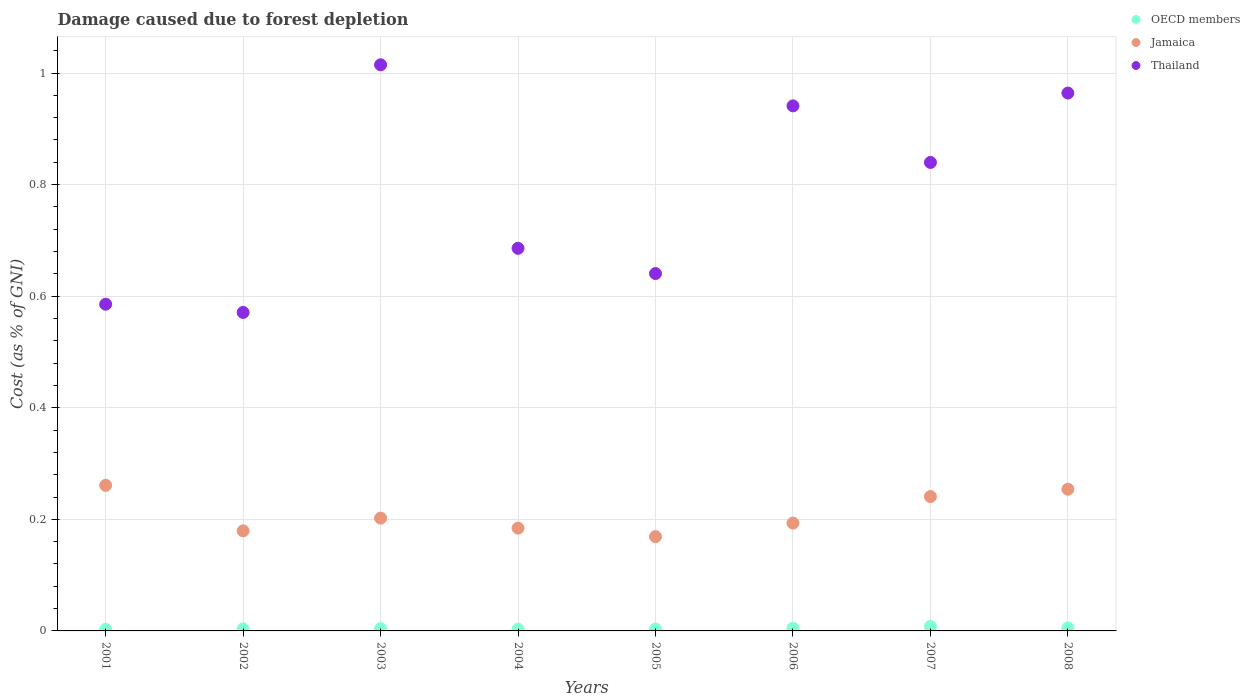How many different coloured dotlines are there?
Keep it short and to the point. 3. Is the number of dotlines equal to the number of legend labels?
Your response must be concise. Yes. What is the cost of damage caused due to forest depletion in Jamaica in 2003?
Make the answer very short. 0.2. Across all years, what is the maximum cost of damage caused due to forest depletion in Thailand?
Your answer should be very brief. 1.01. Across all years, what is the minimum cost of damage caused due to forest depletion in Thailand?
Provide a succinct answer. 0.57. In which year was the cost of damage caused due to forest depletion in Thailand maximum?
Keep it short and to the point. 2003. In which year was the cost of damage caused due to forest depletion in OECD members minimum?
Offer a terse response. 2001. What is the total cost of damage caused due to forest depletion in Jamaica in the graph?
Your answer should be very brief. 1.68. What is the difference between the cost of damage caused due to forest depletion in OECD members in 2001 and that in 2004?
Make the answer very short. -0. What is the difference between the cost of damage caused due to forest depletion in Jamaica in 2004 and the cost of damage caused due to forest depletion in Thailand in 2008?
Your answer should be very brief. -0.78. What is the average cost of damage caused due to forest depletion in Jamaica per year?
Give a very brief answer. 0.21. In the year 2008, what is the difference between the cost of damage caused due to forest depletion in Jamaica and cost of damage caused due to forest depletion in OECD members?
Offer a very short reply. 0.25. What is the ratio of the cost of damage caused due to forest depletion in Jamaica in 2002 to that in 2003?
Give a very brief answer. 0.89. Is the cost of damage caused due to forest depletion in OECD members in 2002 less than that in 2003?
Provide a succinct answer. Yes. Is the difference between the cost of damage caused due to forest depletion in Jamaica in 2007 and 2008 greater than the difference between the cost of damage caused due to forest depletion in OECD members in 2007 and 2008?
Offer a terse response. No. What is the difference between the highest and the second highest cost of damage caused due to forest depletion in Thailand?
Your response must be concise. 0.05. What is the difference between the highest and the lowest cost of damage caused due to forest depletion in Jamaica?
Give a very brief answer. 0.09. In how many years, is the cost of damage caused due to forest depletion in Thailand greater than the average cost of damage caused due to forest depletion in Thailand taken over all years?
Your answer should be very brief. 4. Is the sum of the cost of damage caused due to forest depletion in Jamaica in 2001 and 2002 greater than the maximum cost of damage caused due to forest depletion in Thailand across all years?
Your response must be concise. No. Is the cost of damage caused due to forest depletion in Thailand strictly less than the cost of damage caused due to forest depletion in OECD members over the years?
Make the answer very short. No. Are the values on the major ticks of Y-axis written in scientific E-notation?
Provide a succinct answer. No. Where does the legend appear in the graph?
Ensure brevity in your answer.  Top right. How many legend labels are there?
Offer a very short reply. 3. What is the title of the graph?
Your answer should be compact. Damage caused due to forest depletion. What is the label or title of the X-axis?
Give a very brief answer. Years. What is the label or title of the Y-axis?
Offer a very short reply. Cost (as % of GNI). What is the Cost (as % of GNI) in OECD members in 2001?
Your answer should be compact. 0. What is the Cost (as % of GNI) of Jamaica in 2001?
Provide a succinct answer. 0.26. What is the Cost (as % of GNI) in Thailand in 2001?
Provide a succinct answer. 0.59. What is the Cost (as % of GNI) of OECD members in 2002?
Provide a succinct answer. 0. What is the Cost (as % of GNI) of Jamaica in 2002?
Your response must be concise. 0.18. What is the Cost (as % of GNI) in Thailand in 2002?
Your response must be concise. 0.57. What is the Cost (as % of GNI) of OECD members in 2003?
Your answer should be compact. 0. What is the Cost (as % of GNI) of Jamaica in 2003?
Ensure brevity in your answer.  0.2. What is the Cost (as % of GNI) of Thailand in 2003?
Your response must be concise. 1.01. What is the Cost (as % of GNI) in OECD members in 2004?
Make the answer very short. 0. What is the Cost (as % of GNI) of Jamaica in 2004?
Your answer should be very brief. 0.18. What is the Cost (as % of GNI) in Thailand in 2004?
Offer a terse response. 0.69. What is the Cost (as % of GNI) of OECD members in 2005?
Make the answer very short. 0. What is the Cost (as % of GNI) in Jamaica in 2005?
Provide a short and direct response. 0.17. What is the Cost (as % of GNI) in Thailand in 2005?
Give a very brief answer. 0.64. What is the Cost (as % of GNI) of OECD members in 2006?
Give a very brief answer. 0. What is the Cost (as % of GNI) in Jamaica in 2006?
Provide a succinct answer. 0.19. What is the Cost (as % of GNI) in Thailand in 2006?
Your answer should be compact. 0.94. What is the Cost (as % of GNI) in OECD members in 2007?
Your answer should be compact. 0.01. What is the Cost (as % of GNI) of Jamaica in 2007?
Offer a very short reply. 0.24. What is the Cost (as % of GNI) of Thailand in 2007?
Provide a succinct answer. 0.84. What is the Cost (as % of GNI) of OECD members in 2008?
Make the answer very short. 0.01. What is the Cost (as % of GNI) of Jamaica in 2008?
Keep it short and to the point. 0.25. What is the Cost (as % of GNI) of Thailand in 2008?
Provide a short and direct response. 0.96. Across all years, what is the maximum Cost (as % of GNI) in OECD members?
Your response must be concise. 0.01. Across all years, what is the maximum Cost (as % of GNI) of Jamaica?
Offer a very short reply. 0.26. Across all years, what is the maximum Cost (as % of GNI) in Thailand?
Keep it short and to the point. 1.01. Across all years, what is the minimum Cost (as % of GNI) of OECD members?
Provide a succinct answer. 0. Across all years, what is the minimum Cost (as % of GNI) in Jamaica?
Offer a very short reply. 0.17. Across all years, what is the minimum Cost (as % of GNI) in Thailand?
Offer a terse response. 0.57. What is the total Cost (as % of GNI) in OECD members in the graph?
Your answer should be compact. 0.04. What is the total Cost (as % of GNI) of Jamaica in the graph?
Give a very brief answer. 1.68. What is the total Cost (as % of GNI) in Thailand in the graph?
Offer a terse response. 6.24. What is the difference between the Cost (as % of GNI) of OECD members in 2001 and that in 2002?
Your answer should be compact. -0. What is the difference between the Cost (as % of GNI) in Jamaica in 2001 and that in 2002?
Offer a very short reply. 0.08. What is the difference between the Cost (as % of GNI) of Thailand in 2001 and that in 2002?
Your response must be concise. 0.01. What is the difference between the Cost (as % of GNI) in OECD members in 2001 and that in 2003?
Offer a terse response. -0. What is the difference between the Cost (as % of GNI) in Jamaica in 2001 and that in 2003?
Your response must be concise. 0.06. What is the difference between the Cost (as % of GNI) in Thailand in 2001 and that in 2003?
Your answer should be very brief. -0.43. What is the difference between the Cost (as % of GNI) in OECD members in 2001 and that in 2004?
Provide a short and direct response. -0. What is the difference between the Cost (as % of GNI) in Jamaica in 2001 and that in 2004?
Offer a terse response. 0.08. What is the difference between the Cost (as % of GNI) of Thailand in 2001 and that in 2004?
Provide a short and direct response. -0.1. What is the difference between the Cost (as % of GNI) of OECD members in 2001 and that in 2005?
Make the answer very short. -0. What is the difference between the Cost (as % of GNI) in Jamaica in 2001 and that in 2005?
Your answer should be compact. 0.09. What is the difference between the Cost (as % of GNI) in Thailand in 2001 and that in 2005?
Ensure brevity in your answer.  -0.06. What is the difference between the Cost (as % of GNI) in OECD members in 2001 and that in 2006?
Provide a short and direct response. -0. What is the difference between the Cost (as % of GNI) in Jamaica in 2001 and that in 2006?
Provide a succinct answer. 0.07. What is the difference between the Cost (as % of GNI) in Thailand in 2001 and that in 2006?
Keep it short and to the point. -0.36. What is the difference between the Cost (as % of GNI) of OECD members in 2001 and that in 2007?
Offer a very short reply. -0. What is the difference between the Cost (as % of GNI) of Jamaica in 2001 and that in 2007?
Keep it short and to the point. 0.02. What is the difference between the Cost (as % of GNI) in Thailand in 2001 and that in 2007?
Your response must be concise. -0.25. What is the difference between the Cost (as % of GNI) of OECD members in 2001 and that in 2008?
Your answer should be very brief. -0. What is the difference between the Cost (as % of GNI) of Jamaica in 2001 and that in 2008?
Keep it short and to the point. 0.01. What is the difference between the Cost (as % of GNI) in Thailand in 2001 and that in 2008?
Your answer should be compact. -0.38. What is the difference between the Cost (as % of GNI) in OECD members in 2002 and that in 2003?
Provide a succinct answer. -0. What is the difference between the Cost (as % of GNI) of Jamaica in 2002 and that in 2003?
Your answer should be compact. -0.02. What is the difference between the Cost (as % of GNI) of Thailand in 2002 and that in 2003?
Provide a succinct answer. -0.44. What is the difference between the Cost (as % of GNI) in OECD members in 2002 and that in 2004?
Your answer should be compact. 0. What is the difference between the Cost (as % of GNI) of Jamaica in 2002 and that in 2004?
Your answer should be very brief. -0. What is the difference between the Cost (as % of GNI) in Thailand in 2002 and that in 2004?
Give a very brief answer. -0.12. What is the difference between the Cost (as % of GNI) in OECD members in 2002 and that in 2005?
Offer a terse response. 0. What is the difference between the Cost (as % of GNI) of Jamaica in 2002 and that in 2005?
Keep it short and to the point. 0.01. What is the difference between the Cost (as % of GNI) in Thailand in 2002 and that in 2005?
Make the answer very short. -0.07. What is the difference between the Cost (as % of GNI) of OECD members in 2002 and that in 2006?
Your response must be concise. -0. What is the difference between the Cost (as % of GNI) in Jamaica in 2002 and that in 2006?
Ensure brevity in your answer.  -0.01. What is the difference between the Cost (as % of GNI) in Thailand in 2002 and that in 2006?
Offer a very short reply. -0.37. What is the difference between the Cost (as % of GNI) of OECD members in 2002 and that in 2007?
Offer a terse response. -0. What is the difference between the Cost (as % of GNI) in Jamaica in 2002 and that in 2007?
Offer a terse response. -0.06. What is the difference between the Cost (as % of GNI) in Thailand in 2002 and that in 2007?
Your answer should be compact. -0.27. What is the difference between the Cost (as % of GNI) in OECD members in 2002 and that in 2008?
Your answer should be compact. -0. What is the difference between the Cost (as % of GNI) of Jamaica in 2002 and that in 2008?
Your answer should be compact. -0.07. What is the difference between the Cost (as % of GNI) of Thailand in 2002 and that in 2008?
Ensure brevity in your answer.  -0.39. What is the difference between the Cost (as % of GNI) of OECD members in 2003 and that in 2004?
Offer a terse response. 0. What is the difference between the Cost (as % of GNI) of Jamaica in 2003 and that in 2004?
Your answer should be compact. 0.02. What is the difference between the Cost (as % of GNI) in Thailand in 2003 and that in 2004?
Your answer should be very brief. 0.33. What is the difference between the Cost (as % of GNI) of OECD members in 2003 and that in 2005?
Give a very brief answer. 0. What is the difference between the Cost (as % of GNI) of Jamaica in 2003 and that in 2005?
Offer a terse response. 0.03. What is the difference between the Cost (as % of GNI) in Thailand in 2003 and that in 2005?
Provide a succinct answer. 0.37. What is the difference between the Cost (as % of GNI) in OECD members in 2003 and that in 2006?
Your answer should be compact. -0. What is the difference between the Cost (as % of GNI) in Jamaica in 2003 and that in 2006?
Ensure brevity in your answer.  0.01. What is the difference between the Cost (as % of GNI) of Thailand in 2003 and that in 2006?
Make the answer very short. 0.07. What is the difference between the Cost (as % of GNI) of OECD members in 2003 and that in 2007?
Offer a very short reply. -0. What is the difference between the Cost (as % of GNI) in Jamaica in 2003 and that in 2007?
Your answer should be compact. -0.04. What is the difference between the Cost (as % of GNI) in Thailand in 2003 and that in 2007?
Provide a succinct answer. 0.17. What is the difference between the Cost (as % of GNI) in OECD members in 2003 and that in 2008?
Offer a very short reply. -0. What is the difference between the Cost (as % of GNI) of Jamaica in 2003 and that in 2008?
Your answer should be very brief. -0.05. What is the difference between the Cost (as % of GNI) of Thailand in 2003 and that in 2008?
Provide a short and direct response. 0.05. What is the difference between the Cost (as % of GNI) of OECD members in 2004 and that in 2005?
Ensure brevity in your answer.  -0. What is the difference between the Cost (as % of GNI) in Jamaica in 2004 and that in 2005?
Your response must be concise. 0.02. What is the difference between the Cost (as % of GNI) of Thailand in 2004 and that in 2005?
Provide a succinct answer. 0.05. What is the difference between the Cost (as % of GNI) in OECD members in 2004 and that in 2006?
Provide a short and direct response. -0. What is the difference between the Cost (as % of GNI) in Jamaica in 2004 and that in 2006?
Keep it short and to the point. -0.01. What is the difference between the Cost (as % of GNI) of Thailand in 2004 and that in 2006?
Your response must be concise. -0.26. What is the difference between the Cost (as % of GNI) of OECD members in 2004 and that in 2007?
Make the answer very short. -0. What is the difference between the Cost (as % of GNI) of Jamaica in 2004 and that in 2007?
Offer a terse response. -0.06. What is the difference between the Cost (as % of GNI) in Thailand in 2004 and that in 2007?
Keep it short and to the point. -0.15. What is the difference between the Cost (as % of GNI) in OECD members in 2004 and that in 2008?
Your answer should be very brief. -0. What is the difference between the Cost (as % of GNI) of Jamaica in 2004 and that in 2008?
Your response must be concise. -0.07. What is the difference between the Cost (as % of GNI) of Thailand in 2004 and that in 2008?
Give a very brief answer. -0.28. What is the difference between the Cost (as % of GNI) of OECD members in 2005 and that in 2006?
Your response must be concise. -0. What is the difference between the Cost (as % of GNI) of Jamaica in 2005 and that in 2006?
Your answer should be compact. -0.02. What is the difference between the Cost (as % of GNI) in Thailand in 2005 and that in 2006?
Provide a short and direct response. -0.3. What is the difference between the Cost (as % of GNI) of OECD members in 2005 and that in 2007?
Your response must be concise. -0. What is the difference between the Cost (as % of GNI) in Jamaica in 2005 and that in 2007?
Make the answer very short. -0.07. What is the difference between the Cost (as % of GNI) of Thailand in 2005 and that in 2007?
Your response must be concise. -0.2. What is the difference between the Cost (as % of GNI) in OECD members in 2005 and that in 2008?
Give a very brief answer. -0. What is the difference between the Cost (as % of GNI) of Jamaica in 2005 and that in 2008?
Your response must be concise. -0.09. What is the difference between the Cost (as % of GNI) of Thailand in 2005 and that in 2008?
Your answer should be compact. -0.32. What is the difference between the Cost (as % of GNI) of OECD members in 2006 and that in 2007?
Provide a short and direct response. -0. What is the difference between the Cost (as % of GNI) in Jamaica in 2006 and that in 2007?
Offer a terse response. -0.05. What is the difference between the Cost (as % of GNI) of Thailand in 2006 and that in 2007?
Ensure brevity in your answer.  0.1. What is the difference between the Cost (as % of GNI) in OECD members in 2006 and that in 2008?
Your answer should be very brief. -0. What is the difference between the Cost (as % of GNI) of Jamaica in 2006 and that in 2008?
Offer a very short reply. -0.06. What is the difference between the Cost (as % of GNI) in Thailand in 2006 and that in 2008?
Give a very brief answer. -0.02. What is the difference between the Cost (as % of GNI) in OECD members in 2007 and that in 2008?
Your answer should be very brief. 0. What is the difference between the Cost (as % of GNI) in Jamaica in 2007 and that in 2008?
Ensure brevity in your answer.  -0.01. What is the difference between the Cost (as % of GNI) in Thailand in 2007 and that in 2008?
Give a very brief answer. -0.12. What is the difference between the Cost (as % of GNI) of OECD members in 2001 and the Cost (as % of GNI) of Jamaica in 2002?
Make the answer very short. -0.18. What is the difference between the Cost (as % of GNI) of OECD members in 2001 and the Cost (as % of GNI) of Thailand in 2002?
Provide a succinct answer. -0.57. What is the difference between the Cost (as % of GNI) in Jamaica in 2001 and the Cost (as % of GNI) in Thailand in 2002?
Your answer should be very brief. -0.31. What is the difference between the Cost (as % of GNI) in OECD members in 2001 and the Cost (as % of GNI) in Jamaica in 2003?
Your answer should be compact. -0.2. What is the difference between the Cost (as % of GNI) of OECD members in 2001 and the Cost (as % of GNI) of Thailand in 2003?
Offer a very short reply. -1.01. What is the difference between the Cost (as % of GNI) in Jamaica in 2001 and the Cost (as % of GNI) in Thailand in 2003?
Offer a terse response. -0.75. What is the difference between the Cost (as % of GNI) in OECD members in 2001 and the Cost (as % of GNI) in Jamaica in 2004?
Ensure brevity in your answer.  -0.18. What is the difference between the Cost (as % of GNI) in OECD members in 2001 and the Cost (as % of GNI) in Thailand in 2004?
Offer a very short reply. -0.68. What is the difference between the Cost (as % of GNI) of Jamaica in 2001 and the Cost (as % of GNI) of Thailand in 2004?
Provide a short and direct response. -0.42. What is the difference between the Cost (as % of GNI) in OECD members in 2001 and the Cost (as % of GNI) in Jamaica in 2005?
Provide a short and direct response. -0.17. What is the difference between the Cost (as % of GNI) in OECD members in 2001 and the Cost (as % of GNI) in Thailand in 2005?
Give a very brief answer. -0.64. What is the difference between the Cost (as % of GNI) of Jamaica in 2001 and the Cost (as % of GNI) of Thailand in 2005?
Your answer should be very brief. -0.38. What is the difference between the Cost (as % of GNI) of OECD members in 2001 and the Cost (as % of GNI) of Jamaica in 2006?
Give a very brief answer. -0.19. What is the difference between the Cost (as % of GNI) in OECD members in 2001 and the Cost (as % of GNI) in Thailand in 2006?
Offer a very short reply. -0.94. What is the difference between the Cost (as % of GNI) in Jamaica in 2001 and the Cost (as % of GNI) in Thailand in 2006?
Provide a succinct answer. -0.68. What is the difference between the Cost (as % of GNI) of OECD members in 2001 and the Cost (as % of GNI) of Jamaica in 2007?
Your response must be concise. -0.24. What is the difference between the Cost (as % of GNI) of OECD members in 2001 and the Cost (as % of GNI) of Thailand in 2007?
Your answer should be very brief. -0.84. What is the difference between the Cost (as % of GNI) of Jamaica in 2001 and the Cost (as % of GNI) of Thailand in 2007?
Give a very brief answer. -0.58. What is the difference between the Cost (as % of GNI) in OECD members in 2001 and the Cost (as % of GNI) in Jamaica in 2008?
Make the answer very short. -0.25. What is the difference between the Cost (as % of GNI) in OECD members in 2001 and the Cost (as % of GNI) in Thailand in 2008?
Give a very brief answer. -0.96. What is the difference between the Cost (as % of GNI) of Jamaica in 2001 and the Cost (as % of GNI) of Thailand in 2008?
Keep it short and to the point. -0.7. What is the difference between the Cost (as % of GNI) of OECD members in 2002 and the Cost (as % of GNI) of Jamaica in 2003?
Ensure brevity in your answer.  -0.2. What is the difference between the Cost (as % of GNI) of OECD members in 2002 and the Cost (as % of GNI) of Thailand in 2003?
Make the answer very short. -1.01. What is the difference between the Cost (as % of GNI) of Jamaica in 2002 and the Cost (as % of GNI) of Thailand in 2003?
Your answer should be compact. -0.84. What is the difference between the Cost (as % of GNI) of OECD members in 2002 and the Cost (as % of GNI) of Jamaica in 2004?
Provide a succinct answer. -0.18. What is the difference between the Cost (as % of GNI) of OECD members in 2002 and the Cost (as % of GNI) of Thailand in 2004?
Keep it short and to the point. -0.68. What is the difference between the Cost (as % of GNI) in Jamaica in 2002 and the Cost (as % of GNI) in Thailand in 2004?
Offer a very short reply. -0.51. What is the difference between the Cost (as % of GNI) of OECD members in 2002 and the Cost (as % of GNI) of Jamaica in 2005?
Your response must be concise. -0.17. What is the difference between the Cost (as % of GNI) of OECD members in 2002 and the Cost (as % of GNI) of Thailand in 2005?
Give a very brief answer. -0.64. What is the difference between the Cost (as % of GNI) in Jamaica in 2002 and the Cost (as % of GNI) in Thailand in 2005?
Keep it short and to the point. -0.46. What is the difference between the Cost (as % of GNI) in OECD members in 2002 and the Cost (as % of GNI) in Jamaica in 2006?
Your response must be concise. -0.19. What is the difference between the Cost (as % of GNI) of OECD members in 2002 and the Cost (as % of GNI) of Thailand in 2006?
Give a very brief answer. -0.94. What is the difference between the Cost (as % of GNI) of Jamaica in 2002 and the Cost (as % of GNI) of Thailand in 2006?
Offer a very short reply. -0.76. What is the difference between the Cost (as % of GNI) of OECD members in 2002 and the Cost (as % of GNI) of Jamaica in 2007?
Offer a very short reply. -0.24. What is the difference between the Cost (as % of GNI) of OECD members in 2002 and the Cost (as % of GNI) of Thailand in 2007?
Your answer should be very brief. -0.84. What is the difference between the Cost (as % of GNI) in Jamaica in 2002 and the Cost (as % of GNI) in Thailand in 2007?
Provide a short and direct response. -0.66. What is the difference between the Cost (as % of GNI) of OECD members in 2002 and the Cost (as % of GNI) of Jamaica in 2008?
Give a very brief answer. -0.25. What is the difference between the Cost (as % of GNI) of OECD members in 2002 and the Cost (as % of GNI) of Thailand in 2008?
Make the answer very short. -0.96. What is the difference between the Cost (as % of GNI) of Jamaica in 2002 and the Cost (as % of GNI) of Thailand in 2008?
Make the answer very short. -0.78. What is the difference between the Cost (as % of GNI) in OECD members in 2003 and the Cost (as % of GNI) in Jamaica in 2004?
Provide a succinct answer. -0.18. What is the difference between the Cost (as % of GNI) of OECD members in 2003 and the Cost (as % of GNI) of Thailand in 2004?
Ensure brevity in your answer.  -0.68. What is the difference between the Cost (as % of GNI) of Jamaica in 2003 and the Cost (as % of GNI) of Thailand in 2004?
Your response must be concise. -0.48. What is the difference between the Cost (as % of GNI) of OECD members in 2003 and the Cost (as % of GNI) of Jamaica in 2005?
Ensure brevity in your answer.  -0.16. What is the difference between the Cost (as % of GNI) of OECD members in 2003 and the Cost (as % of GNI) of Thailand in 2005?
Give a very brief answer. -0.64. What is the difference between the Cost (as % of GNI) in Jamaica in 2003 and the Cost (as % of GNI) in Thailand in 2005?
Your answer should be very brief. -0.44. What is the difference between the Cost (as % of GNI) in OECD members in 2003 and the Cost (as % of GNI) in Jamaica in 2006?
Your answer should be very brief. -0.19. What is the difference between the Cost (as % of GNI) in OECD members in 2003 and the Cost (as % of GNI) in Thailand in 2006?
Your answer should be very brief. -0.94. What is the difference between the Cost (as % of GNI) in Jamaica in 2003 and the Cost (as % of GNI) in Thailand in 2006?
Offer a terse response. -0.74. What is the difference between the Cost (as % of GNI) in OECD members in 2003 and the Cost (as % of GNI) in Jamaica in 2007?
Offer a very short reply. -0.24. What is the difference between the Cost (as % of GNI) of OECD members in 2003 and the Cost (as % of GNI) of Thailand in 2007?
Provide a short and direct response. -0.84. What is the difference between the Cost (as % of GNI) in Jamaica in 2003 and the Cost (as % of GNI) in Thailand in 2007?
Your response must be concise. -0.64. What is the difference between the Cost (as % of GNI) of OECD members in 2003 and the Cost (as % of GNI) of Jamaica in 2008?
Make the answer very short. -0.25. What is the difference between the Cost (as % of GNI) of OECD members in 2003 and the Cost (as % of GNI) of Thailand in 2008?
Your answer should be compact. -0.96. What is the difference between the Cost (as % of GNI) in Jamaica in 2003 and the Cost (as % of GNI) in Thailand in 2008?
Offer a very short reply. -0.76. What is the difference between the Cost (as % of GNI) of OECD members in 2004 and the Cost (as % of GNI) of Jamaica in 2005?
Your response must be concise. -0.17. What is the difference between the Cost (as % of GNI) in OECD members in 2004 and the Cost (as % of GNI) in Thailand in 2005?
Your answer should be compact. -0.64. What is the difference between the Cost (as % of GNI) of Jamaica in 2004 and the Cost (as % of GNI) of Thailand in 2005?
Keep it short and to the point. -0.46. What is the difference between the Cost (as % of GNI) in OECD members in 2004 and the Cost (as % of GNI) in Jamaica in 2006?
Make the answer very short. -0.19. What is the difference between the Cost (as % of GNI) of OECD members in 2004 and the Cost (as % of GNI) of Thailand in 2006?
Make the answer very short. -0.94. What is the difference between the Cost (as % of GNI) in Jamaica in 2004 and the Cost (as % of GNI) in Thailand in 2006?
Offer a terse response. -0.76. What is the difference between the Cost (as % of GNI) of OECD members in 2004 and the Cost (as % of GNI) of Jamaica in 2007?
Provide a short and direct response. -0.24. What is the difference between the Cost (as % of GNI) of OECD members in 2004 and the Cost (as % of GNI) of Thailand in 2007?
Your answer should be very brief. -0.84. What is the difference between the Cost (as % of GNI) of Jamaica in 2004 and the Cost (as % of GNI) of Thailand in 2007?
Your answer should be very brief. -0.66. What is the difference between the Cost (as % of GNI) in OECD members in 2004 and the Cost (as % of GNI) in Jamaica in 2008?
Provide a short and direct response. -0.25. What is the difference between the Cost (as % of GNI) of OECD members in 2004 and the Cost (as % of GNI) of Thailand in 2008?
Keep it short and to the point. -0.96. What is the difference between the Cost (as % of GNI) of Jamaica in 2004 and the Cost (as % of GNI) of Thailand in 2008?
Ensure brevity in your answer.  -0.78. What is the difference between the Cost (as % of GNI) in OECD members in 2005 and the Cost (as % of GNI) in Jamaica in 2006?
Your answer should be compact. -0.19. What is the difference between the Cost (as % of GNI) in OECD members in 2005 and the Cost (as % of GNI) in Thailand in 2006?
Keep it short and to the point. -0.94. What is the difference between the Cost (as % of GNI) of Jamaica in 2005 and the Cost (as % of GNI) of Thailand in 2006?
Provide a short and direct response. -0.77. What is the difference between the Cost (as % of GNI) in OECD members in 2005 and the Cost (as % of GNI) in Jamaica in 2007?
Provide a short and direct response. -0.24. What is the difference between the Cost (as % of GNI) of OECD members in 2005 and the Cost (as % of GNI) of Thailand in 2007?
Provide a succinct answer. -0.84. What is the difference between the Cost (as % of GNI) of Jamaica in 2005 and the Cost (as % of GNI) of Thailand in 2007?
Provide a short and direct response. -0.67. What is the difference between the Cost (as % of GNI) in OECD members in 2005 and the Cost (as % of GNI) in Jamaica in 2008?
Your response must be concise. -0.25. What is the difference between the Cost (as % of GNI) in OECD members in 2005 and the Cost (as % of GNI) in Thailand in 2008?
Ensure brevity in your answer.  -0.96. What is the difference between the Cost (as % of GNI) in Jamaica in 2005 and the Cost (as % of GNI) in Thailand in 2008?
Your response must be concise. -0.8. What is the difference between the Cost (as % of GNI) of OECD members in 2006 and the Cost (as % of GNI) of Jamaica in 2007?
Provide a short and direct response. -0.24. What is the difference between the Cost (as % of GNI) of OECD members in 2006 and the Cost (as % of GNI) of Thailand in 2007?
Keep it short and to the point. -0.83. What is the difference between the Cost (as % of GNI) in Jamaica in 2006 and the Cost (as % of GNI) in Thailand in 2007?
Your answer should be very brief. -0.65. What is the difference between the Cost (as % of GNI) of OECD members in 2006 and the Cost (as % of GNI) of Jamaica in 2008?
Your answer should be compact. -0.25. What is the difference between the Cost (as % of GNI) in OECD members in 2006 and the Cost (as % of GNI) in Thailand in 2008?
Your response must be concise. -0.96. What is the difference between the Cost (as % of GNI) of Jamaica in 2006 and the Cost (as % of GNI) of Thailand in 2008?
Offer a very short reply. -0.77. What is the difference between the Cost (as % of GNI) of OECD members in 2007 and the Cost (as % of GNI) of Jamaica in 2008?
Your answer should be very brief. -0.25. What is the difference between the Cost (as % of GNI) of OECD members in 2007 and the Cost (as % of GNI) of Thailand in 2008?
Offer a very short reply. -0.96. What is the difference between the Cost (as % of GNI) of Jamaica in 2007 and the Cost (as % of GNI) of Thailand in 2008?
Offer a very short reply. -0.72. What is the average Cost (as % of GNI) of OECD members per year?
Offer a terse response. 0. What is the average Cost (as % of GNI) of Jamaica per year?
Ensure brevity in your answer.  0.21. What is the average Cost (as % of GNI) of Thailand per year?
Provide a succinct answer. 0.78. In the year 2001, what is the difference between the Cost (as % of GNI) of OECD members and Cost (as % of GNI) of Jamaica?
Make the answer very short. -0.26. In the year 2001, what is the difference between the Cost (as % of GNI) in OECD members and Cost (as % of GNI) in Thailand?
Provide a short and direct response. -0.58. In the year 2001, what is the difference between the Cost (as % of GNI) of Jamaica and Cost (as % of GNI) of Thailand?
Make the answer very short. -0.32. In the year 2002, what is the difference between the Cost (as % of GNI) in OECD members and Cost (as % of GNI) in Jamaica?
Keep it short and to the point. -0.18. In the year 2002, what is the difference between the Cost (as % of GNI) in OECD members and Cost (as % of GNI) in Thailand?
Your response must be concise. -0.57. In the year 2002, what is the difference between the Cost (as % of GNI) in Jamaica and Cost (as % of GNI) in Thailand?
Offer a terse response. -0.39. In the year 2003, what is the difference between the Cost (as % of GNI) in OECD members and Cost (as % of GNI) in Jamaica?
Ensure brevity in your answer.  -0.2. In the year 2003, what is the difference between the Cost (as % of GNI) in OECD members and Cost (as % of GNI) in Thailand?
Your answer should be compact. -1.01. In the year 2003, what is the difference between the Cost (as % of GNI) in Jamaica and Cost (as % of GNI) in Thailand?
Your answer should be very brief. -0.81. In the year 2004, what is the difference between the Cost (as % of GNI) of OECD members and Cost (as % of GNI) of Jamaica?
Provide a succinct answer. -0.18. In the year 2004, what is the difference between the Cost (as % of GNI) in OECD members and Cost (as % of GNI) in Thailand?
Keep it short and to the point. -0.68. In the year 2004, what is the difference between the Cost (as % of GNI) of Jamaica and Cost (as % of GNI) of Thailand?
Offer a very short reply. -0.5. In the year 2005, what is the difference between the Cost (as % of GNI) of OECD members and Cost (as % of GNI) of Jamaica?
Your answer should be compact. -0.17. In the year 2005, what is the difference between the Cost (as % of GNI) in OECD members and Cost (as % of GNI) in Thailand?
Ensure brevity in your answer.  -0.64. In the year 2005, what is the difference between the Cost (as % of GNI) in Jamaica and Cost (as % of GNI) in Thailand?
Provide a succinct answer. -0.47. In the year 2006, what is the difference between the Cost (as % of GNI) of OECD members and Cost (as % of GNI) of Jamaica?
Ensure brevity in your answer.  -0.19. In the year 2006, what is the difference between the Cost (as % of GNI) of OECD members and Cost (as % of GNI) of Thailand?
Offer a terse response. -0.94. In the year 2006, what is the difference between the Cost (as % of GNI) of Jamaica and Cost (as % of GNI) of Thailand?
Give a very brief answer. -0.75. In the year 2007, what is the difference between the Cost (as % of GNI) in OECD members and Cost (as % of GNI) in Jamaica?
Keep it short and to the point. -0.23. In the year 2007, what is the difference between the Cost (as % of GNI) in OECD members and Cost (as % of GNI) in Thailand?
Make the answer very short. -0.83. In the year 2007, what is the difference between the Cost (as % of GNI) of Jamaica and Cost (as % of GNI) of Thailand?
Give a very brief answer. -0.6. In the year 2008, what is the difference between the Cost (as % of GNI) of OECD members and Cost (as % of GNI) of Jamaica?
Your answer should be compact. -0.25. In the year 2008, what is the difference between the Cost (as % of GNI) in OECD members and Cost (as % of GNI) in Thailand?
Provide a short and direct response. -0.96. In the year 2008, what is the difference between the Cost (as % of GNI) in Jamaica and Cost (as % of GNI) in Thailand?
Make the answer very short. -0.71. What is the ratio of the Cost (as % of GNI) in OECD members in 2001 to that in 2002?
Make the answer very short. 0.81. What is the ratio of the Cost (as % of GNI) in Jamaica in 2001 to that in 2002?
Ensure brevity in your answer.  1.45. What is the ratio of the Cost (as % of GNI) in Thailand in 2001 to that in 2002?
Your answer should be compact. 1.03. What is the ratio of the Cost (as % of GNI) of OECD members in 2001 to that in 2003?
Keep it short and to the point. 0.72. What is the ratio of the Cost (as % of GNI) of Jamaica in 2001 to that in 2003?
Offer a terse response. 1.29. What is the ratio of the Cost (as % of GNI) of Thailand in 2001 to that in 2003?
Offer a very short reply. 0.58. What is the ratio of the Cost (as % of GNI) of OECD members in 2001 to that in 2004?
Make the answer very short. 0.93. What is the ratio of the Cost (as % of GNI) in Jamaica in 2001 to that in 2004?
Give a very brief answer. 1.42. What is the ratio of the Cost (as % of GNI) of Thailand in 2001 to that in 2004?
Provide a succinct answer. 0.85. What is the ratio of the Cost (as % of GNI) of OECD members in 2001 to that in 2005?
Keep it short and to the point. 0.84. What is the ratio of the Cost (as % of GNI) of Jamaica in 2001 to that in 2005?
Make the answer very short. 1.54. What is the ratio of the Cost (as % of GNI) of Thailand in 2001 to that in 2005?
Your answer should be very brief. 0.91. What is the ratio of the Cost (as % of GNI) of OECD members in 2001 to that in 2006?
Ensure brevity in your answer.  0.62. What is the ratio of the Cost (as % of GNI) in Jamaica in 2001 to that in 2006?
Give a very brief answer. 1.35. What is the ratio of the Cost (as % of GNI) in Thailand in 2001 to that in 2006?
Your response must be concise. 0.62. What is the ratio of the Cost (as % of GNI) of OECD members in 2001 to that in 2007?
Provide a short and direct response. 0.38. What is the ratio of the Cost (as % of GNI) in Jamaica in 2001 to that in 2007?
Your answer should be compact. 1.08. What is the ratio of the Cost (as % of GNI) in Thailand in 2001 to that in 2007?
Offer a very short reply. 0.7. What is the ratio of the Cost (as % of GNI) of OECD members in 2001 to that in 2008?
Keep it short and to the point. 0.54. What is the ratio of the Cost (as % of GNI) in Jamaica in 2001 to that in 2008?
Ensure brevity in your answer.  1.03. What is the ratio of the Cost (as % of GNI) of Thailand in 2001 to that in 2008?
Your answer should be compact. 0.61. What is the ratio of the Cost (as % of GNI) in OECD members in 2002 to that in 2003?
Your answer should be compact. 0.89. What is the ratio of the Cost (as % of GNI) of Jamaica in 2002 to that in 2003?
Provide a short and direct response. 0.89. What is the ratio of the Cost (as % of GNI) of Thailand in 2002 to that in 2003?
Provide a succinct answer. 0.56. What is the ratio of the Cost (as % of GNI) in OECD members in 2002 to that in 2004?
Keep it short and to the point. 1.15. What is the ratio of the Cost (as % of GNI) of Jamaica in 2002 to that in 2004?
Your answer should be very brief. 0.97. What is the ratio of the Cost (as % of GNI) in Thailand in 2002 to that in 2004?
Ensure brevity in your answer.  0.83. What is the ratio of the Cost (as % of GNI) of OECD members in 2002 to that in 2005?
Make the answer very short. 1.04. What is the ratio of the Cost (as % of GNI) of Jamaica in 2002 to that in 2005?
Give a very brief answer. 1.06. What is the ratio of the Cost (as % of GNI) of Thailand in 2002 to that in 2005?
Provide a short and direct response. 0.89. What is the ratio of the Cost (as % of GNI) of OECD members in 2002 to that in 2006?
Offer a very short reply. 0.77. What is the ratio of the Cost (as % of GNI) in Jamaica in 2002 to that in 2006?
Give a very brief answer. 0.93. What is the ratio of the Cost (as % of GNI) of Thailand in 2002 to that in 2006?
Offer a very short reply. 0.61. What is the ratio of the Cost (as % of GNI) in OECD members in 2002 to that in 2007?
Keep it short and to the point. 0.47. What is the ratio of the Cost (as % of GNI) in Jamaica in 2002 to that in 2007?
Provide a succinct answer. 0.74. What is the ratio of the Cost (as % of GNI) of Thailand in 2002 to that in 2007?
Provide a succinct answer. 0.68. What is the ratio of the Cost (as % of GNI) of OECD members in 2002 to that in 2008?
Your answer should be very brief. 0.67. What is the ratio of the Cost (as % of GNI) in Jamaica in 2002 to that in 2008?
Your response must be concise. 0.71. What is the ratio of the Cost (as % of GNI) in Thailand in 2002 to that in 2008?
Give a very brief answer. 0.59. What is the ratio of the Cost (as % of GNI) of OECD members in 2003 to that in 2004?
Offer a very short reply. 1.29. What is the ratio of the Cost (as % of GNI) in Jamaica in 2003 to that in 2004?
Keep it short and to the point. 1.1. What is the ratio of the Cost (as % of GNI) in Thailand in 2003 to that in 2004?
Your answer should be very brief. 1.48. What is the ratio of the Cost (as % of GNI) of OECD members in 2003 to that in 2005?
Your answer should be very brief. 1.18. What is the ratio of the Cost (as % of GNI) in Jamaica in 2003 to that in 2005?
Ensure brevity in your answer.  1.2. What is the ratio of the Cost (as % of GNI) of Thailand in 2003 to that in 2005?
Your answer should be very brief. 1.58. What is the ratio of the Cost (as % of GNI) of OECD members in 2003 to that in 2006?
Provide a succinct answer. 0.86. What is the ratio of the Cost (as % of GNI) in Jamaica in 2003 to that in 2006?
Make the answer very short. 1.05. What is the ratio of the Cost (as % of GNI) in Thailand in 2003 to that in 2006?
Offer a terse response. 1.08. What is the ratio of the Cost (as % of GNI) of OECD members in 2003 to that in 2007?
Ensure brevity in your answer.  0.53. What is the ratio of the Cost (as % of GNI) of Jamaica in 2003 to that in 2007?
Give a very brief answer. 0.84. What is the ratio of the Cost (as % of GNI) of Thailand in 2003 to that in 2007?
Provide a short and direct response. 1.21. What is the ratio of the Cost (as % of GNI) in OECD members in 2003 to that in 2008?
Give a very brief answer. 0.75. What is the ratio of the Cost (as % of GNI) of Jamaica in 2003 to that in 2008?
Keep it short and to the point. 0.8. What is the ratio of the Cost (as % of GNI) in Thailand in 2003 to that in 2008?
Provide a short and direct response. 1.05. What is the ratio of the Cost (as % of GNI) of OECD members in 2004 to that in 2005?
Ensure brevity in your answer.  0.91. What is the ratio of the Cost (as % of GNI) of Jamaica in 2004 to that in 2005?
Ensure brevity in your answer.  1.09. What is the ratio of the Cost (as % of GNI) in Thailand in 2004 to that in 2005?
Your response must be concise. 1.07. What is the ratio of the Cost (as % of GNI) in OECD members in 2004 to that in 2006?
Offer a very short reply. 0.67. What is the ratio of the Cost (as % of GNI) in Jamaica in 2004 to that in 2006?
Offer a very short reply. 0.95. What is the ratio of the Cost (as % of GNI) of Thailand in 2004 to that in 2006?
Provide a short and direct response. 0.73. What is the ratio of the Cost (as % of GNI) in OECD members in 2004 to that in 2007?
Keep it short and to the point. 0.41. What is the ratio of the Cost (as % of GNI) in Jamaica in 2004 to that in 2007?
Your response must be concise. 0.77. What is the ratio of the Cost (as % of GNI) in Thailand in 2004 to that in 2007?
Provide a succinct answer. 0.82. What is the ratio of the Cost (as % of GNI) in OECD members in 2004 to that in 2008?
Keep it short and to the point. 0.58. What is the ratio of the Cost (as % of GNI) of Jamaica in 2004 to that in 2008?
Offer a very short reply. 0.73. What is the ratio of the Cost (as % of GNI) of Thailand in 2004 to that in 2008?
Your response must be concise. 0.71. What is the ratio of the Cost (as % of GNI) in OECD members in 2005 to that in 2006?
Make the answer very short. 0.73. What is the ratio of the Cost (as % of GNI) in Jamaica in 2005 to that in 2006?
Offer a very short reply. 0.87. What is the ratio of the Cost (as % of GNI) of Thailand in 2005 to that in 2006?
Provide a short and direct response. 0.68. What is the ratio of the Cost (as % of GNI) in OECD members in 2005 to that in 2007?
Offer a terse response. 0.45. What is the ratio of the Cost (as % of GNI) in Jamaica in 2005 to that in 2007?
Your response must be concise. 0.7. What is the ratio of the Cost (as % of GNI) of Thailand in 2005 to that in 2007?
Offer a terse response. 0.76. What is the ratio of the Cost (as % of GNI) in OECD members in 2005 to that in 2008?
Ensure brevity in your answer.  0.64. What is the ratio of the Cost (as % of GNI) of Jamaica in 2005 to that in 2008?
Your answer should be compact. 0.67. What is the ratio of the Cost (as % of GNI) in Thailand in 2005 to that in 2008?
Keep it short and to the point. 0.66. What is the ratio of the Cost (as % of GNI) of OECD members in 2006 to that in 2007?
Offer a very short reply. 0.61. What is the ratio of the Cost (as % of GNI) of Jamaica in 2006 to that in 2007?
Ensure brevity in your answer.  0.8. What is the ratio of the Cost (as % of GNI) in Thailand in 2006 to that in 2007?
Offer a terse response. 1.12. What is the ratio of the Cost (as % of GNI) of OECD members in 2006 to that in 2008?
Your answer should be compact. 0.87. What is the ratio of the Cost (as % of GNI) of Jamaica in 2006 to that in 2008?
Make the answer very short. 0.76. What is the ratio of the Cost (as % of GNI) in Thailand in 2006 to that in 2008?
Offer a very short reply. 0.98. What is the ratio of the Cost (as % of GNI) in OECD members in 2007 to that in 2008?
Your answer should be very brief. 1.43. What is the ratio of the Cost (as % of GNI) of Jamaica in 2007 to that in 2008?
Your answer should be compact. 0.95. What is the ratio of the Cost (as % of GNI) in Thailand in 2007 to that in 2008?
Your response must be concise. 0.87. What is the difference between the highest and the second highest Cost (as % of GNI) of OECD members?
Give a very brief answer. 0. What is the difference between the highest and the second highest Cost (as % of GNI) of Jamaica?
Your answer should be compact. 0.01. What is the difference between the highest and the second highest Cost (as % of GNI) in Thailand?
Make the answer very short. 0.05. What is the difference between the highest and the lowest Cost (as % of GNI) in OECD members?
Offer a terse response. 0. What is the difference between the highest and the lowest Cost (as % of GNI) in Jamaica?
Ensure brevity in your answer.  0.09. What is the difference between the highest and the lowest Cost (as % of GNI) of Thailand?
Provide a succinct answer. 0.44. 